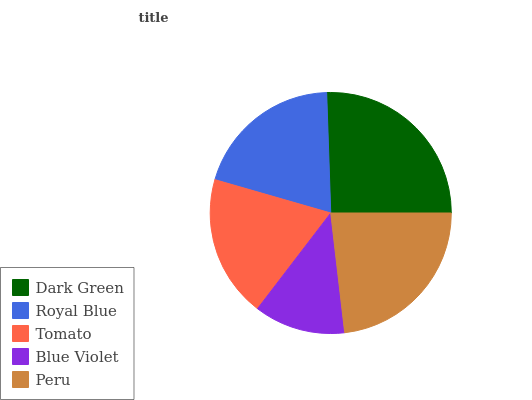Is Blue Violet the minimum?
Answer yes or no. Yes. Is Dark Green the maximum?
Answer yes or no. Yes. Is Royal Blue the minimum?
Answer yes or no. No. Is Royal Blue the maximum?
Answer yes or no. No. Is Dark Green greater than Royal Blue?
Answer yes or no. Yes. Is Royal Blue less than Dark Green?
Answer yes or no. Yes. Is Royal Blue greater than Dark Green?
Answer yes or no. No. Is Dark Green less than Royal Blue?
Answer yes or no. No. Is Royal Blue the high median?
Answer yes or no. Yes. Is Royal Blue the low median?
Answer yes or no. Yes. Is Dark Green the high median?
Answer yes or no. No. Is Tomato the low median?
Answer yes or no. No. 